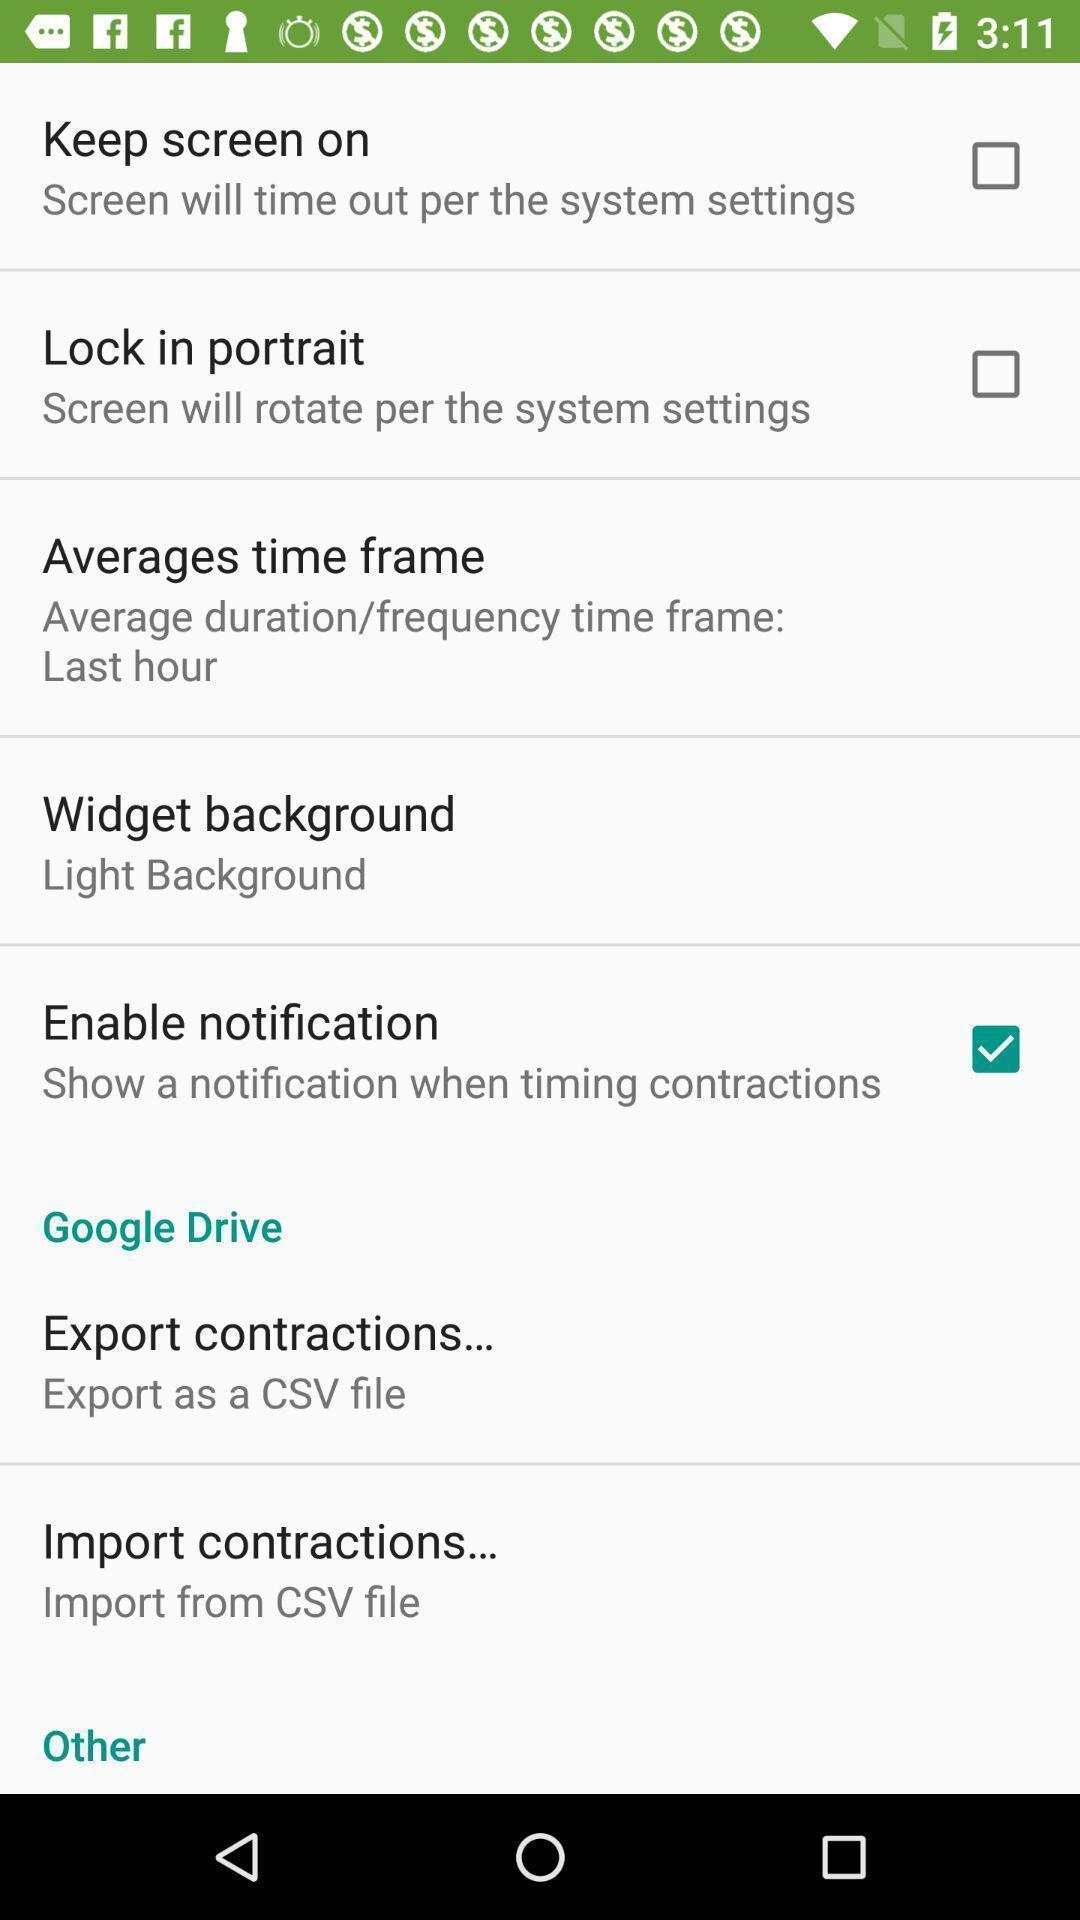Describe the visual elements of this screenshot. Settings page. 